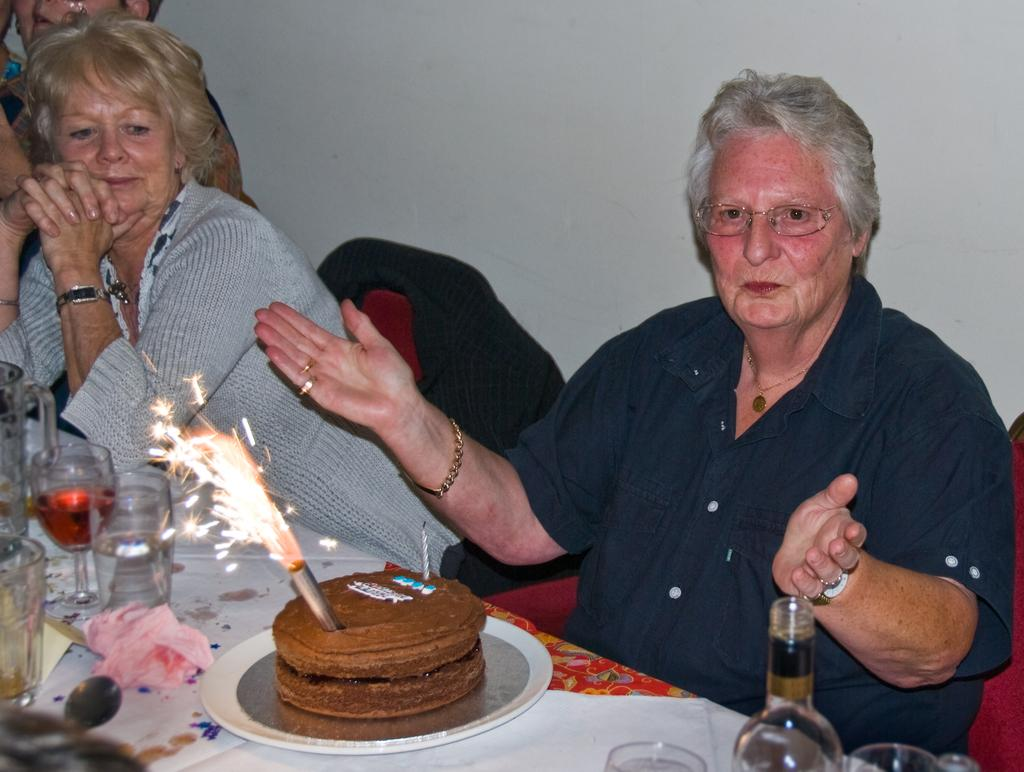What is the man in the image doing? The man is sitting on a chair in the image. What is in front of the man? The man is in front of a cake. Who is sitting beside the man? There is a woman sitting beside the man. What day is it in the image? There is no information about the day in the image. 